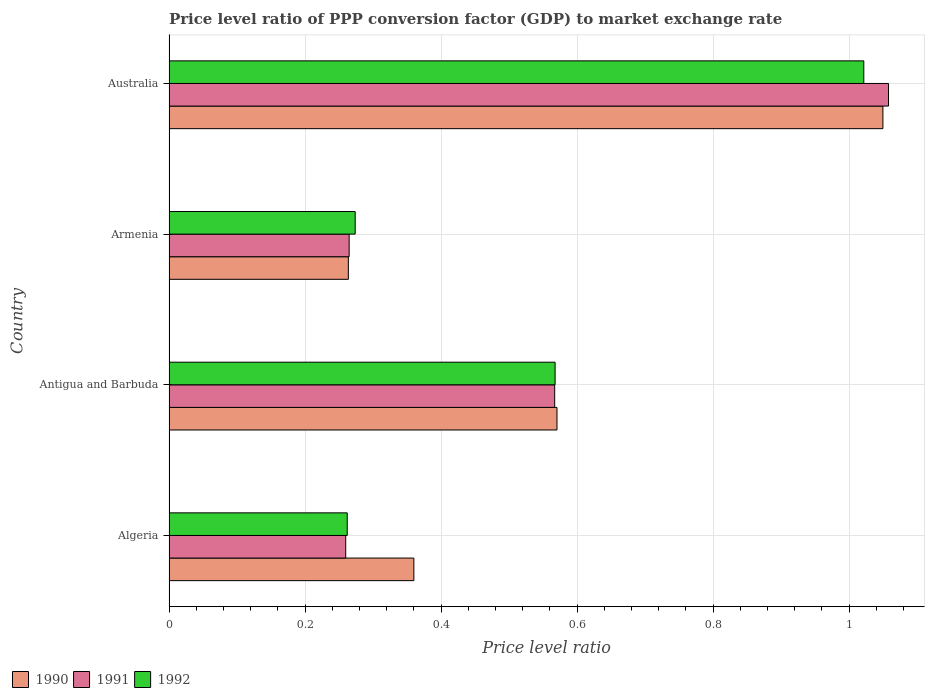Are the number of bars per tick equal to the number of legend labels?
Your response must be concise. Yes. What is the label of the 3rd group of bars from the top?
Your answer should be very brief. Antigua and Barbuda. What is the price level ratio in 1992 in Australia?
Make the answer very short. 1.02. Across all countries, what is the maximum price level ratio in 1991?
Keep it short and to the point. 1.06. Across all countries, what is the minimum price level ratio in 1990?
Provide a short and direct response. 0.26. In which country was the price level ratio in 1991 minimum?
Make the answer very short. Algeria. What is the total price level ratio in 1992 in the graph?
Give a very brief answer. 2.13. What is the difference between the price level ratio in 1990 in Antigua and Barbuda and that in Armenia?
Your answer should be very brief. 0.31. What is the difference between the price level ratio in 1992 in Algeria and the price level ratio in 1991 in Armenia?
Your answer should be very brief. -0. What is the average price level ratio in 1992 per country?
Ensure brevity in your answer.  0.53. What is the difference between the price level ratio in 1990 and price level ratio in 1992 in Algeria?
Your answer should be compact. 0.1. In how many countries, is the price level ratio in 1992 greater than 0.24000000000000002 ?
Offer a terse response. 4. What is the ratio of the price level ratio in 1990 in Armenia to that in Australia?
Keep it short and to the point. 0.25. Is the price level ratio in 1992 in Algeria less than that in Armenia?
Your answer should be compact. Yes. Is the difference between the price level ratio in 1990 in Algeria and Armenia greater than the difference between the price level ratio in 1992 in Algeria and Armenia?
Your answer should be very brief. Yes. What is the difference between the highest and the second highest price level ratio in 1991?
Ensure brevity in your answer.  0.49. What is the difference between the highest and the lowest price level ratio in 1990?
Provide a short and direct response. 0.79. What does the 1st bar from the top in Antigua and Barbuda represents?
Provide a succinct answer. 1992. How many bars are there?
Give a very brief answer. 12. Are the values on the major ticks of X-axis written in scientific E-notation?
Your answer should be very brief. No. Where does the legend appear in the graph?
Offer a very short reply. Bottom left. How many legend labels are there?
Your answer should be very brief. 3. How are the legend labels stacked?
Offer a very short reply. Horizontal. What is the title of the graph?
Ensure brevity in your answer.  Price level ratio of PPP conversion factor (GDP) to market exchange rate. What is the label or title of the X-axis?
Offer a terse response. Price level ratio. What is the Price level ratio in 1990 in Algeria?
Make the answer very short. 0.36. What is the Price level ratio in 1991 in Algeria?
Your response must be concise. 0.26. What is the Price level ratio of 1992 in Algeria?
Offer a very short reply. 0.26. What is the Price level ratio in 1990 in Antigua and Barbuda?
Provide a succinct answer. 0.57. What is the Price level ratio of 1991 in Antigua and Barbuda?
Your response must be concise. 0.57. What is the Price level ratio of 1992 in Antigua and Barbuda?
Your answer should be compact. 0.57. What is the Price level ratio in 1990 in Armenia?
Your answer should be compact. 0.26. What is the Price level ratio of 1991 in Armenia?
Your answer should be compact. 0.26. What is the Price level ratio in 1992 in Armenia?
Your response must be concise. 0.27. What is the Price level ratio in 1990 in Australia?
Provide a succinct answer. 1.05. What is the Price level ratio in 1991 in Australia?
Provide a short and direct response. 1.06. What is the Price level ratio of 1992 in Australia?
Your answer should be very brief. 1.02. Across all countries, what is the maximum Price level ratio of 1990?
Your response must be concise. 1.05. Across all countries, what is the maximum Price level ratio in 1991?
Provide a short and direct response. 1.06. Across all countries, what is the maximum Price level ratio of 1992?
Ensure brevity in your answer.  1.02. Across all countries, what is the minimum Price level ratio of 1990?
Your answer should be very brief. 0.26. Across all countries, what is the minimum Price level ratio of 1991?
Offer a very short reply. 0.26. Across all countries, what is the minimum Price level ratio in 1992?
Ensure brevity in your answer.  0.26. What is the total Price level ratio of 1990 in the graph?
Offer a very short reply. 2.24. What is the total Price level ratio of 1991 in the graph?
Ensure brevity in your answer.  2.15. What is the total Price level ratio in 1992 in the graph?
Ensure brevity in your answer.  2.13. What is the difference between the Price level ratio in 1990 in Algeria and that in Antigua and Barbuda?
Provide a short and direct response. -0.21. What is the difference between the Price level ratio of 1991 in Algeria and that in Antigua and Barbuda?
Ensure brevity in your answer.  -0.31. What is the difference between the Price level ratio of 1992 in Algeria and that in Antigua and Barbuda?
Offer a terse response. -0.31. What is the difference between the Price level ratio in 1990 in Algeria and that in Armenia?
Give a very brief answer. 0.1. What is the difference between the Price level ratio of 1991 in Algeria and that in Armenia?
Keep it short and to the point. -0.01. What is the difference between the Price level ratio of 1992 in Algeria and that in Armenia?
Your response must be concise. -0.01. What is the difference between the Price level ratio of 1990 in Algeria and that in Australia?
Provide a succinct answer. -0.69. What is the difference between the Price level ratio in 1991 in Algeria and that in Australia?
Your response must be concise. -0.8. What is the difference between the Price level ratio of 1992 in Algeria and that in Australia?
Offer a very short reply. -0.76. What is the difference between the Price level ratio of 1990 in Antigua and Barbuda and that in Armenia?
Give a very brief answer. 0.31. What is the difference between the Price level ratio of 1991 in Antigua and Barbuda and that in Armenia?
Provide a short and direct response. 0.3. What is the difference between the Price level ratio in 1992 in Antigua and Barbuda and that in Armenia?
Provide a succinct answer. 0.29. What is the difference between the Price level ratio in 1990 in Antigua and Barbuda and that in Australia?
Your response must be concise. -0.48. What is the difference between the Price level ratio of 1991 in Antigua and Barbuda and that in Australia?
Provide a succinct answer. -0.49. What is the difference between the Price level ratio in 1992 in Antigua and Barbuda and that in Australia?
Keep it short and to the point. -0.45. What is the difference between the Price level ratio in 1990 in Armenia and that in Australia?
Provide a short and direct response. -0.79. What is the difference between the Price level ratio in 1991 in Armenia and that in Australia?
Ensure brevity in your answer.  -0.79. What is the difference between the Price level ratio in 1992 in Armenia and that in Australia?
Keep it short and to the point. -0.75. What is the difference between the Price level ratio in 1990 in Algeria and the Price level ratio in 1991 in Antigua and Barbuda?
Make the answer very short. -0.21. What is the difference between the Price level ratio of 1990 in Algeria and the Price level ratio of 1992 in Antigua and Barbuda?
Your answer should be compact. -0.21. What is the difference between the Price level ratio in 1991 in Algeria and the Price level ratio in 1992 in Antigua and Barbuda?
Your answer should be very brief. -0.31. What is the difference between the Price level ratio in 1990 in Algeria and the Price level ratio in 1991 in Armenia?
Keep it short and to the point. 0.1. What is the difference between the Price level ratio in 1990 in Algeria and the Price level ratio in 1992 in Armenia?
Provide a succinct answer. 0.09. What is the difference between the Price level ratio of 1991 in Algeria and the Price level ratio of 1992 in Armenia?
Your answer should be very brief. -0.01. What is the difference between the Price level ratio in 1990 in Algeria and the Price level ratio in 1991 in Australia?
Make the answer very short. -0.7. What is the difference between the Price level ratio in 1990 in Algeria and the Price level ratio in 1992 in Australia?
Ensure brevity in your answer.  -0.66. What is the difference between the Price level ratio in 1991 in Algeria and the Price level ratio in 1992 in Australia?
Your answer should be very brief. -0.76. What is the difference between the Price level ratio in 1990 in Antigua and Barbuda and the Price level ratio in 1991 in Armenia?
Your answer should be very brief. 0.31. What is the difference between the Price level ratio of 1990 in Antigua and Barbuda and the Price level ratio of 1992 in Armenia?
Ensure brevity in your answer.  0.3. What is the difference between the Price level ratio in 1991 in Antigua and Barbuda and the Price level ratio in 1992 in Armenia?
Offer a terse response. 0.29. What is the difference between the Price level ratio of 1990 in Antigua and Barbuda and the Price level ratio of 1991 in Australia?
Your answer should be very brief. -0.49. What is the difference between the Price level ratio of 1990 in Antigua and Barbuda and the Price level ratio of 1992 in Australia?
Provide a short and direct response. -0.45. What is the difference between the Price level ratio of 1991 in Antigua and Barbuda and the Price level ratio of 1992 in Australia?
Your answer should be compact. -0.45. What is the difference between the Price level ratio in 1990 in Armenia and the Price level ratio in 1991 in Australia?
Your answer should be very brief. -0.79. What is the difference between the Price level ratio of 1990 in Armenia and the Price level ratio of 1992 in Australia?
Give a very brief answer. -0.76. What is the difference between the Price level ratio of 1991 in Armenia and the Price level ratio of 1992 in Australia?
Make the answer very short. -0.76. What is the average Price level ratio in 1990 per country?
Ensure brevity in your answer.  0.56. What is the average Price level ratio of 1991 per country?
Offer a very short reply. 0.54. What is the average Price level ratio of 1992 per country?
Provide a succinct answer. 0.53. What is the difference between the Price level ratio in 1990 and Price level ratio in 1991 in Algeria?
Ensure brevity in your answer.  0.1. What is the difference between the Price level ratio of 1990 and Price level ratio of 1992 in Algeria?
Your response must be concise. 0.1. What is the difference between the Price level ratio in 1991 and Price level ratio in 1992 in Algeria?
Your response must be concise. -0. What is the difference between the Price level ratio in 1990 and Price level ratio in 1991 in Antigua and Barbuda?
Provide a short and direct response. 0. What is the difference between the Price level ratio in 1990 and Price level ratio in 1992 in Antigua and Barbuda?
Provide a succinct answer. 0. What is the difference between the Price level ratio in 1991 and Price level ratio in 1992 in Antigua and Barbuda?
Provide a succinct answer. -0. What is the difference between the Price level ratio of 1990 and Price level ratio of 1991 in Armenia?
Your answer should be compact. -0. What is the difference between the Price level ratio in 1990 and Price level ratio in 1992 in Armenia?
Your answer should be compact. -0.01. What is the difference between the Price level ratio in 1991 and Price level ratio in 1992 in Armenia?
Offer a very short reply. -0.01. What is the difference between the Price level ratio in 1990 and Price level ratio in 1991 in Australia?
Your answer should be very brief. -0.01. What is the difference between the Price level ratio of 1990 and Price level ratio of 1992 in Australia?
Give a very brief answer. 0.03. What is the difference between the Price level ratio in 1991 and Price level ratio in 1992 in Australia?
Keep it short and to the point. 0.04. What is the ratio of the Price level ratio in 1990 in Algeria to that in Antigua and Barbuda?
Give a very brief answer. 0.63. What is the ratio of the Price level ratio in 1991 in Algeria to that in Antigua and Barbuda?
Your answer should be very brief. 0.46. What is the ratio of the Price level ratio in 1992 in Algeria to that in Antigua and Barbuda?
Keep it short and to the point. 0.46. What is the ratio of the Price level ratio in 1990 in Algeria to that in Armenia?
Provide a succinct answer. 1.37. What is the ratio of the Price level ratio of 1992 in Algeria to that in Armenia?
Your response must be concise. 0.96. What is the ratio of the Price level ratio in 1990 in Algeria to that in Australia?
Make the answer very short. 0.34. What is the ratio of the Price level ratio in 1991 in Algeria to that in Australia?
Give a very brief answer. 0.25. What is the ratio of the Price level ratio of 1992 in Algeria to that in Australia?
Ensure brevity in your answer.  0.26. What is the ratio of the Price level ratio in 1990 in Antigua and Barbuda to that in Armenia?
Offer a terse response. 2.16. What is the ratio of the Price level ratio in 1991 in Antigua and Barbuda to that in Armenia?
Give a very brief answer. 2.14. What is the ratio of the Price level ratio in 1992 in Antigua and Barbuda to that in Armenia?
Keep it short and to the point. 2.07. What is the ratio of the Price level ratio of 1990 in Antigua and Barbuda to that in Australia?
Ensure brevity in your answer.  0.54. What is the ratio of the Price level ratio of 1991 in Antigua and Barbuda to that in Australia?
Offer a very short reply. 0.54. What is the ratio of the Price level ratio in 1992 in Antigua and Barbuda to that in Australia?
Make the answer very short. 0.56. What is the ratio of the Price level ratio of 1990 in Armenia to that in Australia?
Offer a terse response. 0.25. What is the ratio of the Price level ratio in 1991 in Armenia to that in Australia?
Provide a succinct answer. 0.25. What is the ratio of the Price level ratio of 1992 in Armenia to that in Australia?
Ensure brevity in your answer.  0.27. What is the difference between the highest and the second highest Price level ratio in 1990?
Provide a succinct answer. 0.48. What is the difference between the highest and the second highest Price level ratio of 1991?
Ensure brevity in your answer.  0.49. What is the difference between the highest and the second highest Price level ratio in 1992?
Ensure brevity in your answer.  0.45. What is the difference between the highest and the lowest Price level ratio of 1990?
Make the answer very short. 0.79. What is the difference between the highest and the lowest Price level ratio in 1991?
Your response must be concise. 0.8. What is the difference between the highest and the lowest Price level ratio of 1992?
Provide a succinct answer. 0.76. 